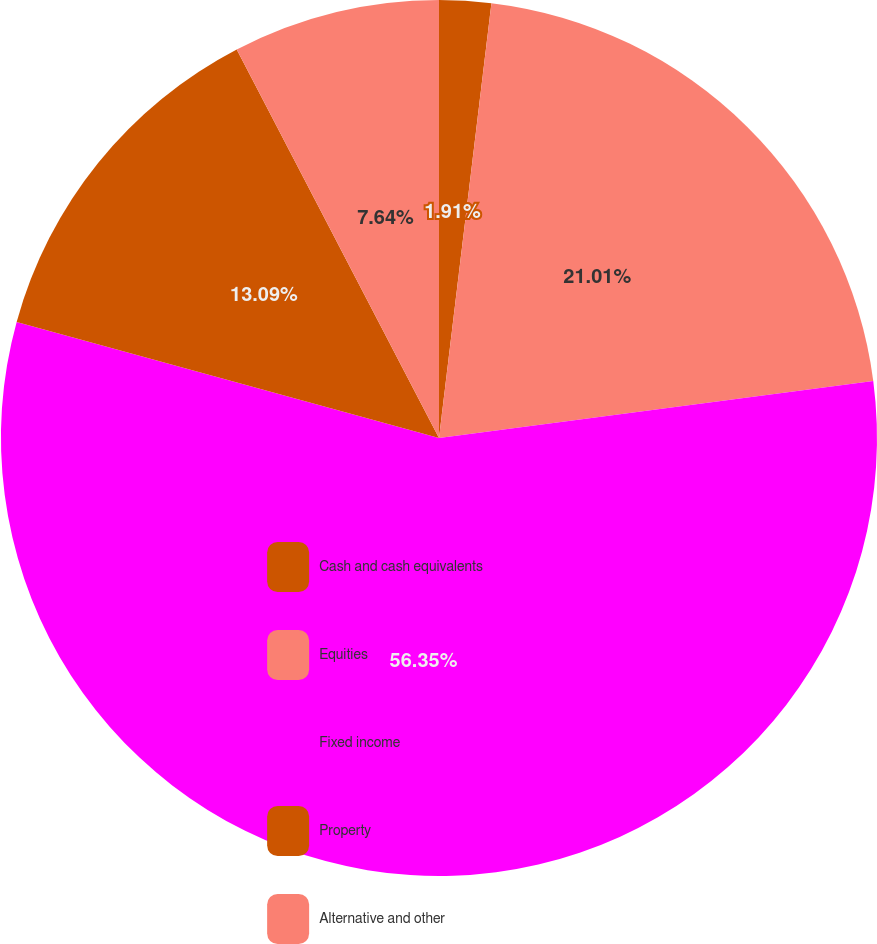Convert chart to OTSL. <chart><loc_0><loc_0><loc_500><loc_500><pie_chart><fcel>Cash and cash equivalents<fcel>Equities<fcel>Fixed income<fcel>Property<fcel>Alternative and other<nl><fcel>1.91%<fcel>21.01%<fcel>56.35%<fcel>13.09%<fcel>7.64%<nl></chart> 